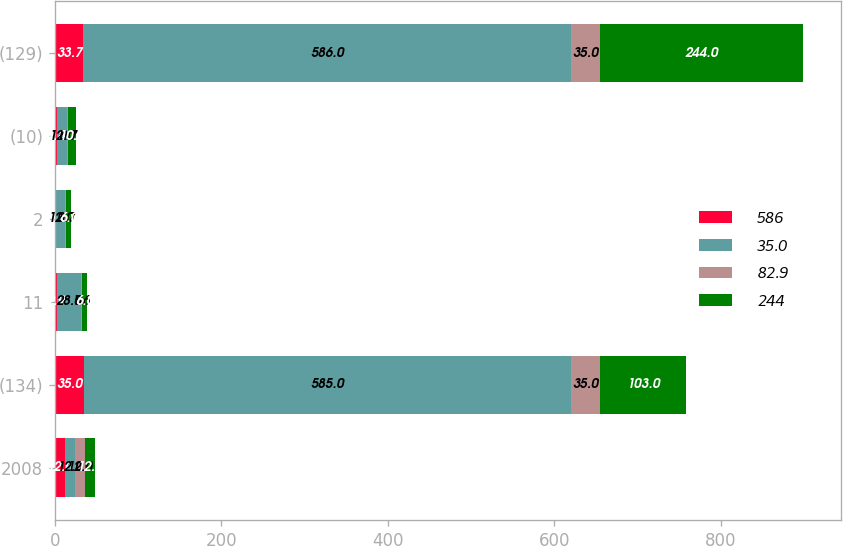<chart> <loc_0><loc_0><loc_500><loc_500><stacked_bar_chart><ecel><fcel>2008<fcel>(134)<fcel>11<fcel>2<fcel>(10)<fcel>(129)<nl><fcel>586<fcel>12<fcel>35<fcel>2.9<fcel>0.5<fcel>2.8<fcel>33.7<nl><fcel>35<fcel>12<fcel>585<fcel>28<fcel>12<fcel>12<fcel>586<nl><fcel>82.9<fcel>12<fcel>35<fcel>1.6<fcel>0.7<fcel>0.7<fcel>35<nl><fcel>244<fcel>12<fcel>103<fcel>6<fcel>6<fcel>10<fcel>244<nl></chart> 